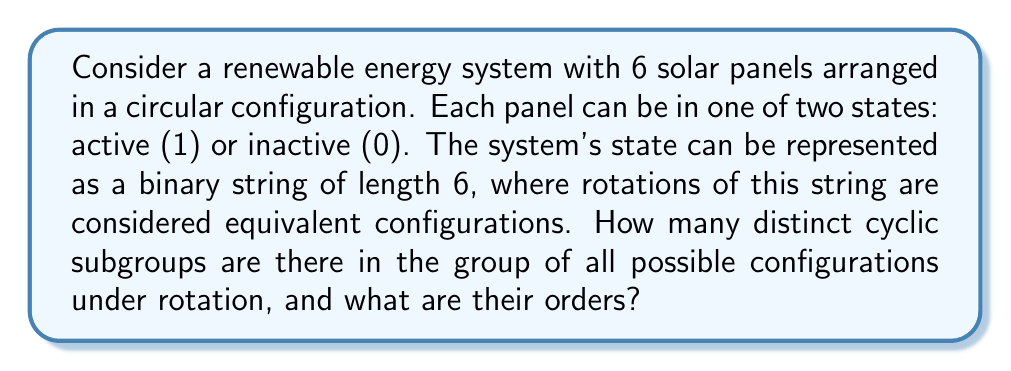Can you solve this math problem? To solve this problem, we need to follow these steps:

1) First, we need to understand that the group of all possible configurations under rotation is isomorphic to the cyclic group $C_6$. This is because there are 6 positions, and rotating the configuration is equivalent to shifting the binary string cyclically.

2) The number of distinct cyclic subgroups in $C_6$ is equal to the number of divisors of 6. The divisors of 6 are 1, 2, 3, and 6.

3) For each divisor $d$ of 6, there is a unique subgroup of order $d$. Let's examine each:

   a) For $d=1$: This is the trivial subgroup $\{000000\}$.
   
   b) For $d=2$: This subgroup consists of the identity and a rotation by 3 positions. 
      It can be generated by $\{000000, 111111\}$.
   
   c) For $d=3$: This subgroup consists of the identity and rotations by 2 and 4 positions. 
      It can be generated by $\{000000, 110110, 101101\}$.
   
   d) For $d=6$: This is the entire group $C_6$.

4) Therefore, there are 4 distinct cyclic subgroups.

5) The orders of these subgroups are 1, 2, 3, and 6, corresponding to the divisors of 6.

This analysis provides insights into the symmetries and periodic behaviors that could occur in the renewable energy system, which is relevant to the sustainable development expert's perspective on eco-friendly community spaces.
Answer: There are 4 distinct cyclic subgroups with orders 1, 2, 3, and 6. 